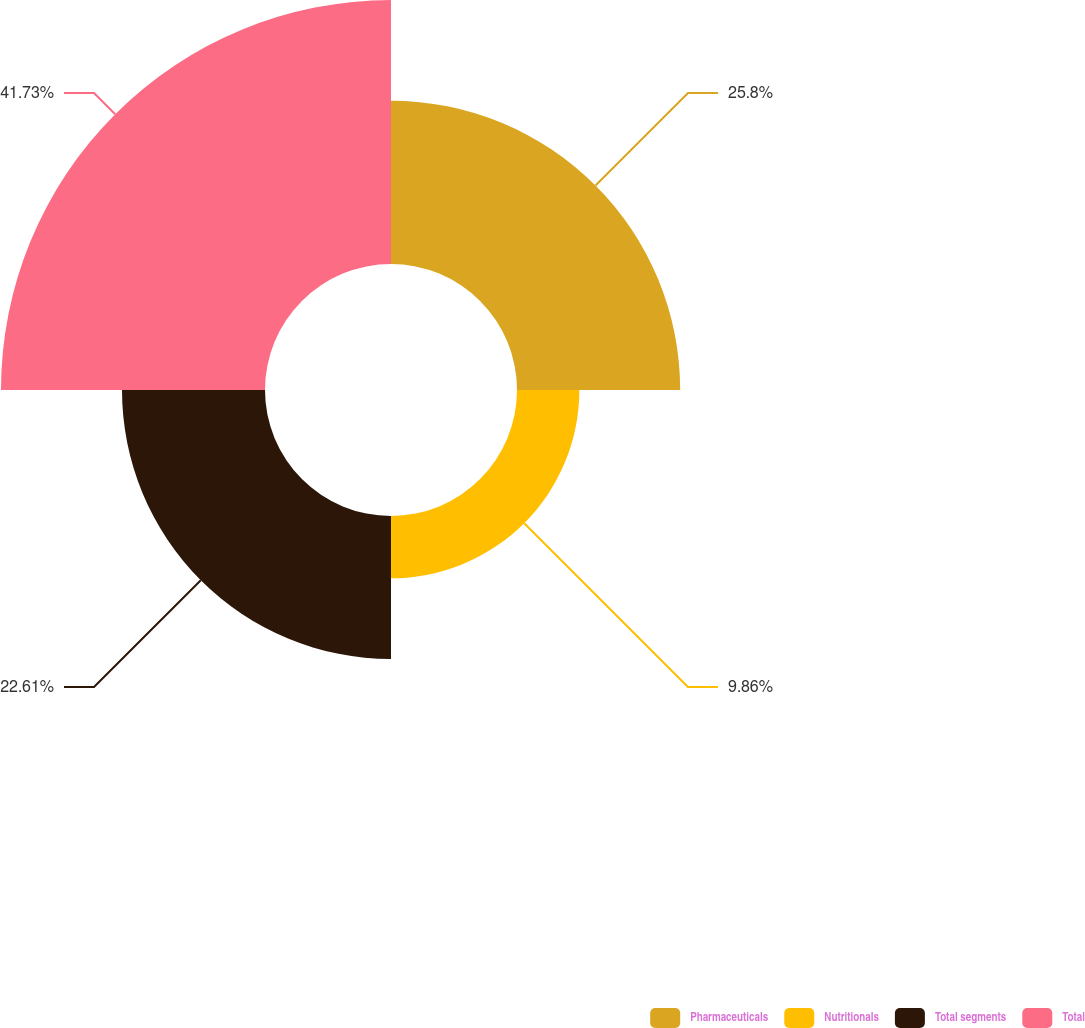Convert chart to OTSL. <chart><loc_0><loc_0><loc_500><loc_500><pie_chart><fcel>Pharmaceuticals<fcel>Nutritionals<fcel>Total segments<fcel>Total<nl><fcel>25.8%<fcel>9.86%<fcel>22.61%<fcel>41.74%<nl></chart> 